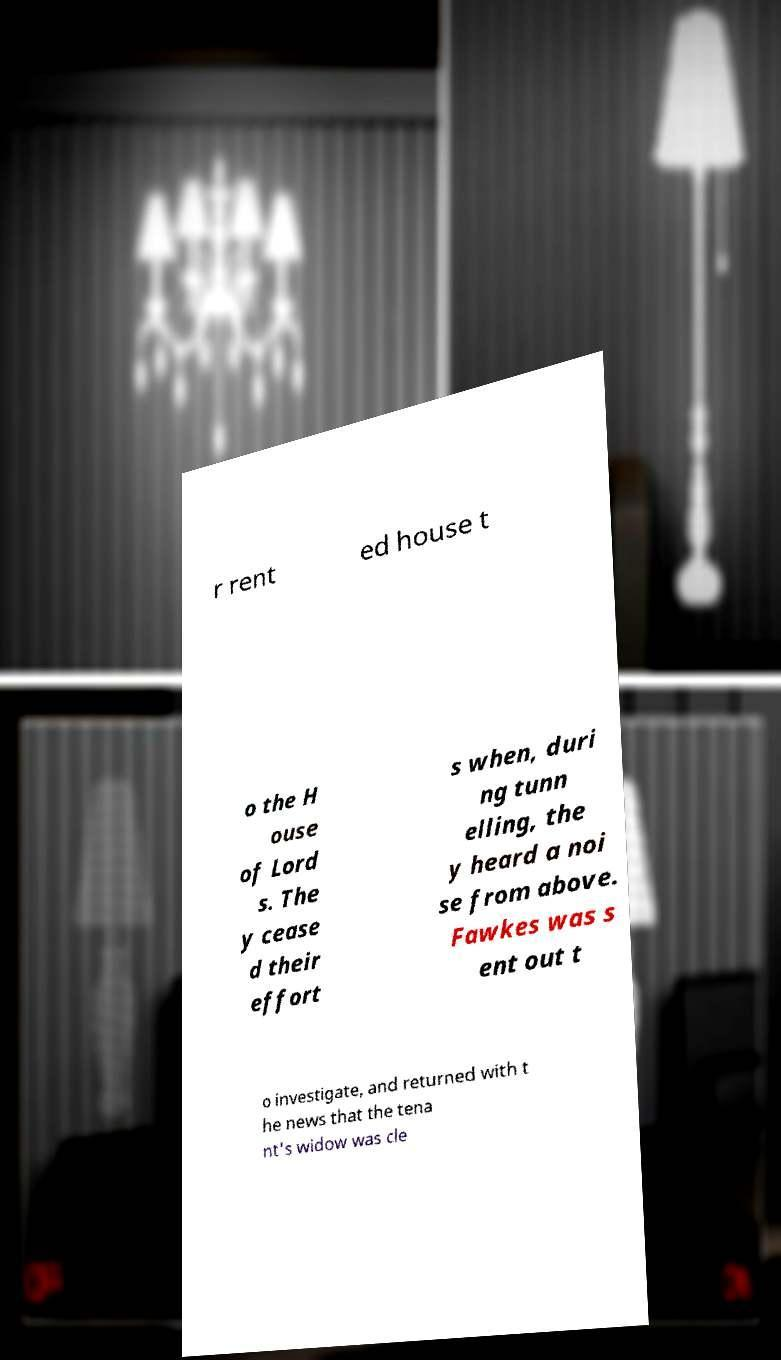Could you extract and type out the text from this image? r rent ed house t o the H ouse of Lord s. The y cease d their effort s when, duri ng tunn elling, the y heard a noi se from above. Fawkes was s ent out t o investigate, and returned with t he news that the tena nt's widow was cle 